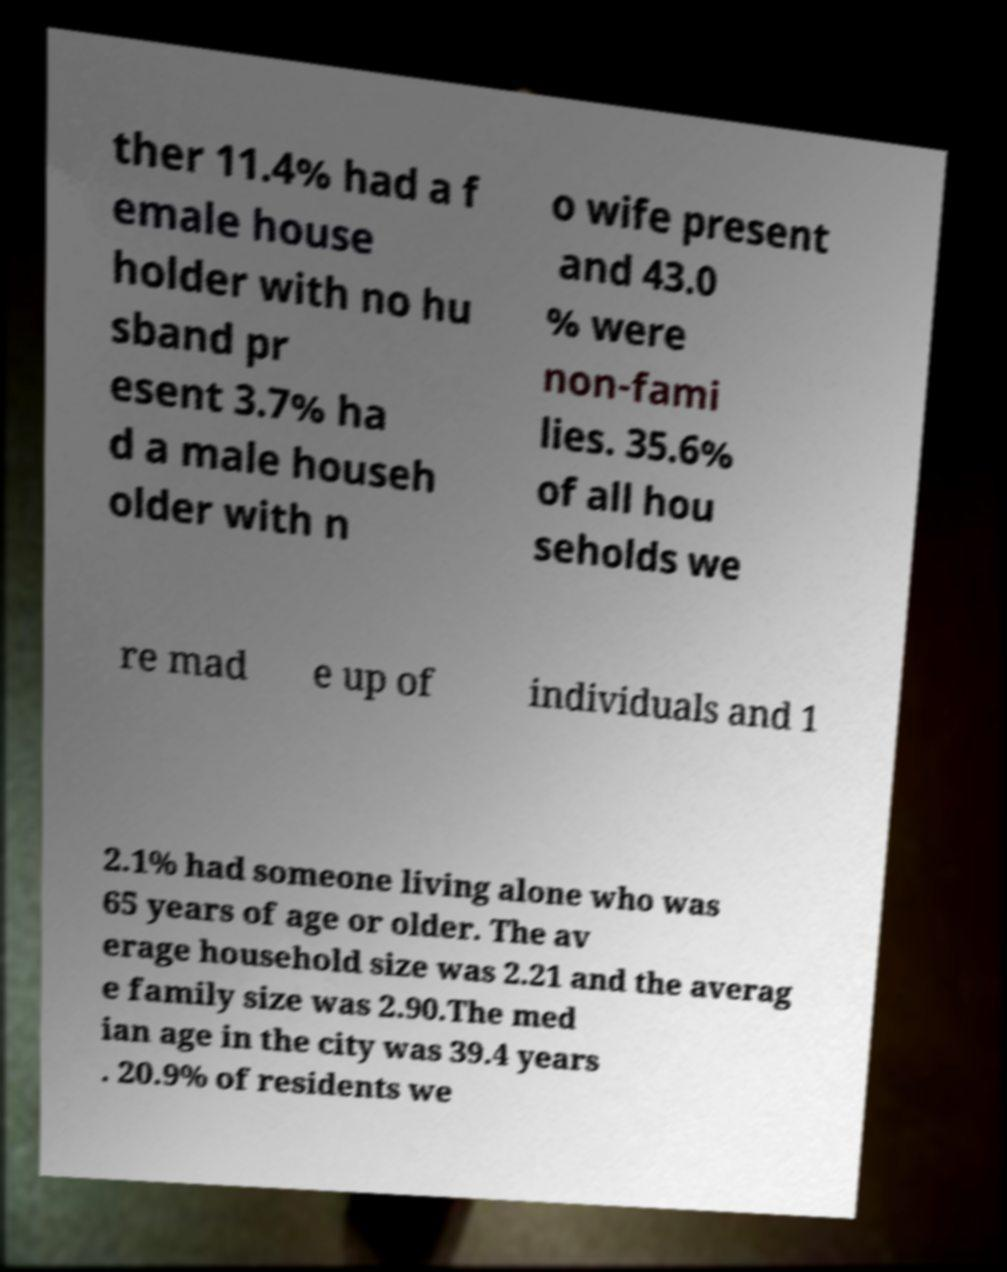Can you accurately transcribe the text from the provided image for me? ther 11.4% had a f emale house holder with no hu sband pr esent 3.7% ha d a male househ older with n o wife present and 43.0 % were non-fami lies. 35.6% of all hou seholds we re mad e up of individuals and 1 2.1% had someone living alone who was 65 years of age or older. The av erage household size was 2.21 and the averag e family size was 2.90.The med ian age in the city was 39.4 years . 20.9% of residents we 